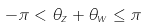Convert formula to latex. <formula><loc_0><loc_0><loc_500><loc_500>- \pi < \theta _ { z } + \theta _ { w } \leq \pi</formula> 